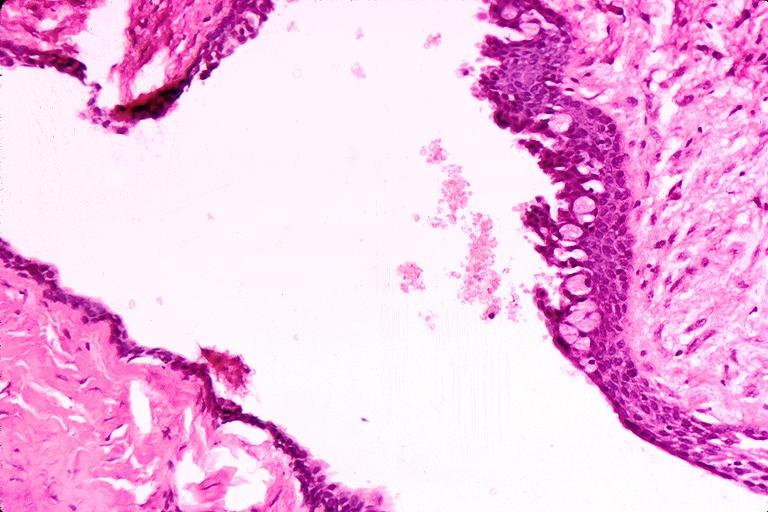what does this image show?
Answer the question using a single word or phrase. Cyst 